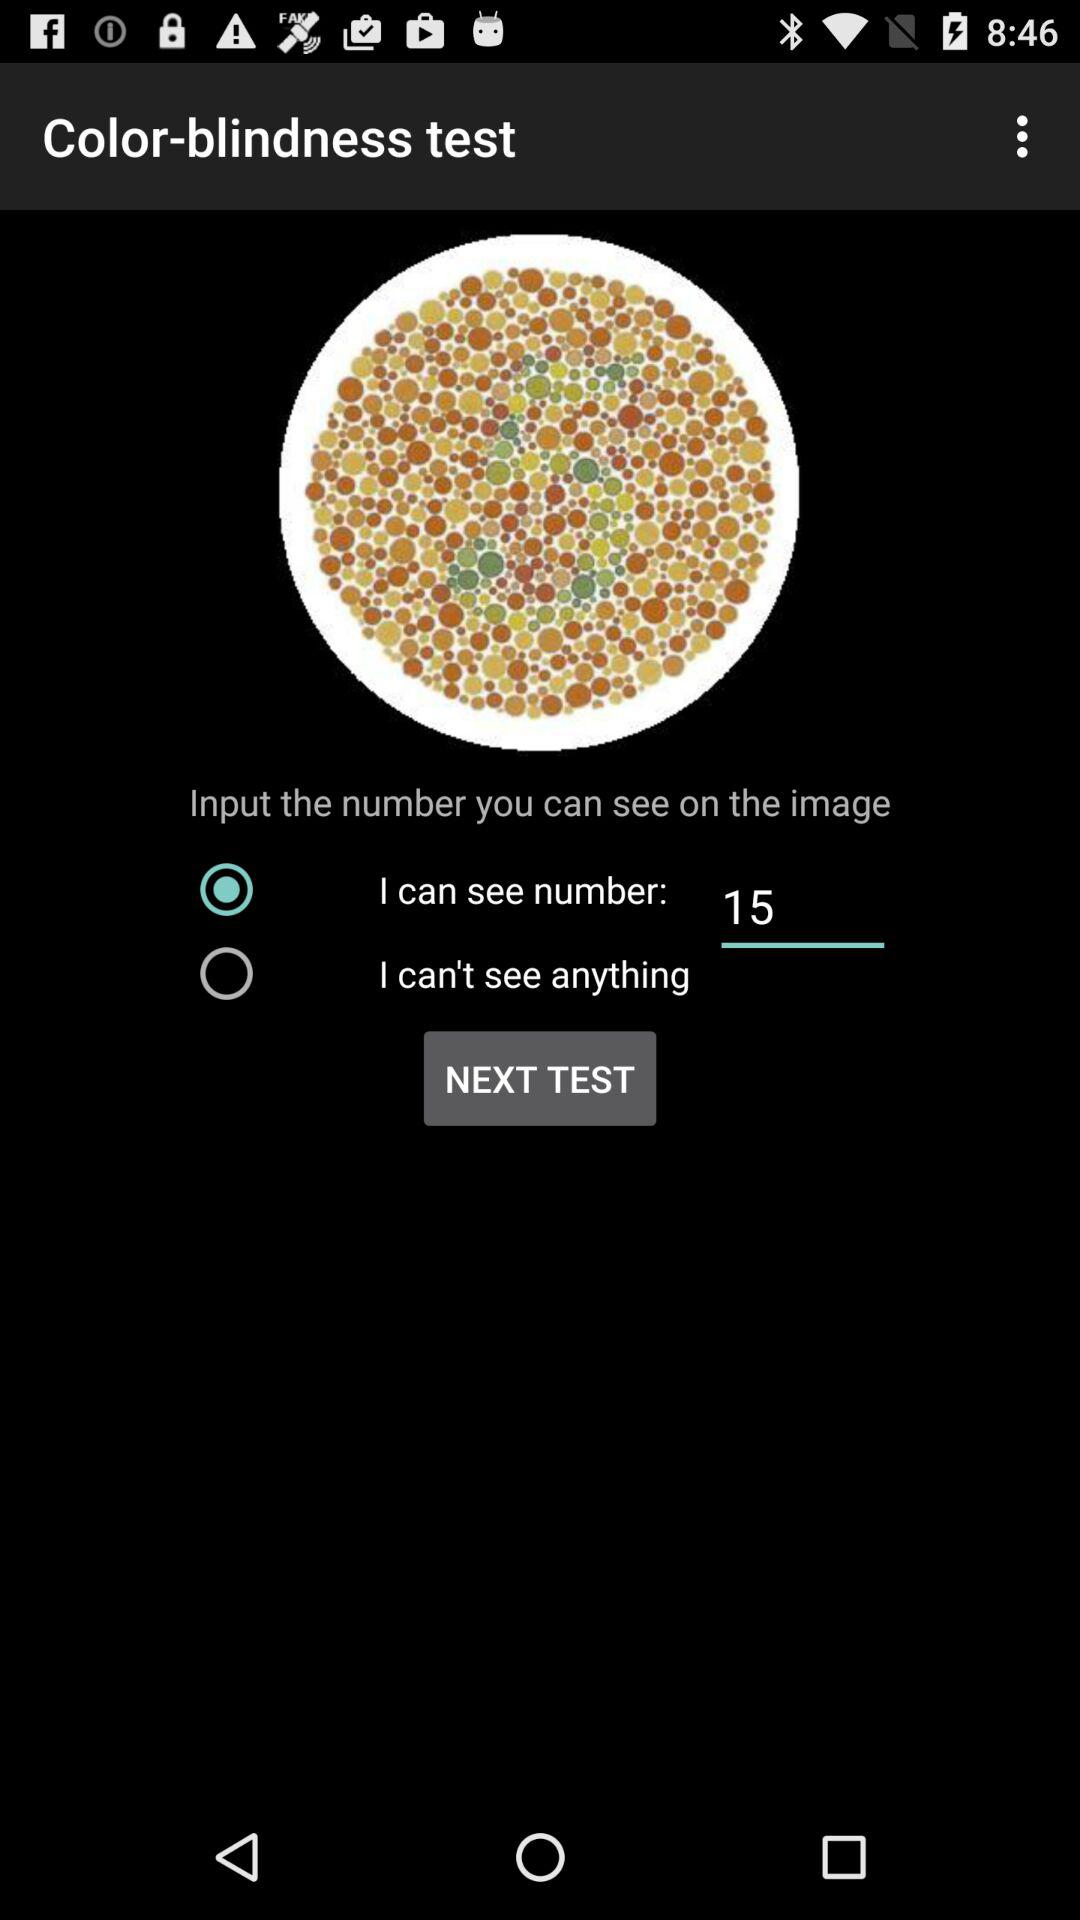What number is visible on the image? The number that is visible on the image is 5. 